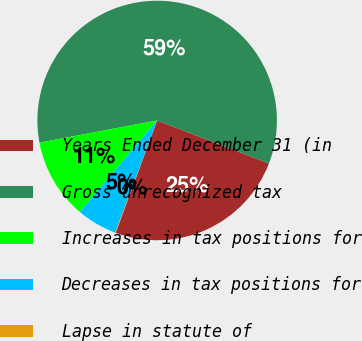Convert chart. <chart><loc_0><loc_0><loc_500><loc_500><pie_chart><fcel>Years Ended December 31 (in<fcel>Gross unrecognized tax<fcel>Increases in tax positions for<fcel>Decreases in tax positions for<fcel>Lapse in statute of<nl><fcel>24.78%<fcel>58.8%<fcel>10.87%<fcel>5.47%<fcel>0.07%<nl></chart> 